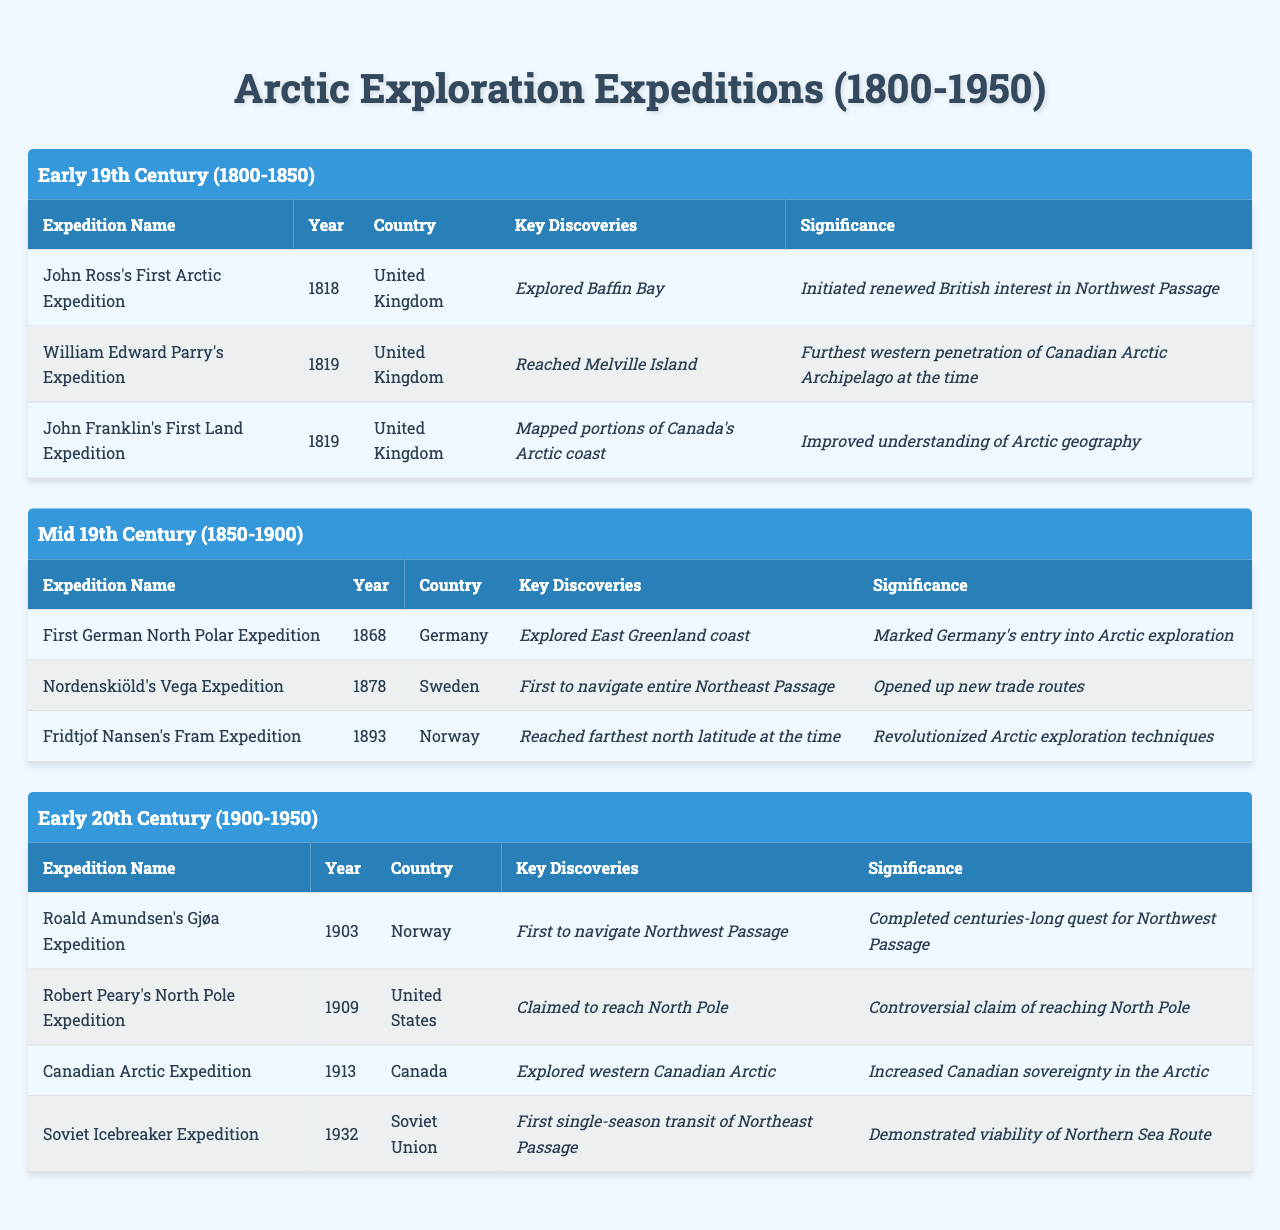What was the first recorded Arctic expedition in the 19th century? The table lists expeditions in chronological order. The first expedition under "Early 19th Century (1800-1850)" is John Ross's First Arctic Expedition in 1818.
Answer: John Ross's First Arctic Expedition Which country conducted the expedition that first navigated the entire Northeast Passage? Looking at the "Mid 19th Century (1850-1900)" era, the Nordenskiöld's Vega Expedition in 1878 is noted for being the first to navigate the entire Northeast Passage, and it was conducted by Sweden.
Answer: Sweden How many expeditions occurred in the Early 20th Century? In the "Early 20th Century (1900-1950)" section, there are four listed expeditions: Roald Amundsen's Gjøa Expedition, Robert Peary's North Pole Expedition, Canadian Arctic Expedition, and Soviet Icebreaker Expedition.
Answer: Four Did the United States claim any significant Arctic territory in its expeditions? The table indicates that Robert Peary's North Pole Expedition in 1909 claimed to reach the North Pole, but this claim is marked as controversial. Therefore, yes, it suggests a claim, but the reliability is questioned.
Answer: Yes What was the significance of the Fram Expedition in 1893? The significance of Fridtjof Nansen's Fram Expedition, listed in the "Mid 19th Century (1850-1900)" era, is mentioned as having revolutionized Arctic exploration techniques, highlighting its importance in the history of exploration.
Answer: Revolutionized Arctic exploration techniques Which expedition had the year with the highest recorded date? By scanning through the table, the expedition with the highest year is the Soviet Icebreaker Expedition in 1932. Therefore, that is the answer.
Answer: 1932 Count the number of expeditions initiated by the United Kingdom. By examining the table across both the "Early 19th Century" and "Mid 19th Century" sections, there are three expeditions initiated by the United Kingdom: John Ross's First Arctic Expedition, William Edward Parry's Expedition, and John Franklin's First Land Expedition, totaling three.
Answer: Three Which expedition is associated with increased Canadian sovereignty in the Arctic? The table specifies that the Canadian Arctic Expedition in 1913 explored the western Canadian Arctic, and its significance is noted as having increased Canadian sovereignty in the region.
Answer: Canadian Arctic Expedition Was there a significant milestone reached by Norwegians in Arctic exploration? Yes, Roald Amundsen's Gjøa Expedition in 1903 is noted for being the first to navigate the Northwest Passage, marking a significant milestone in Norwegian Arctic exploration.
Answer: Yes Compare the significance of the 1868 German expedition to the 1878 Swedish expedition. The 1868 expedition (First German North Polar Expedition) marked Germany's entry into Arctic exploration, while the 1878 expedition (Nordenskiöld's Vega Expedition) is significant for opening up new trade routes. The Swedish expedition had broader implications for exploration and commerce, while the German expedition marked a national point in exploration.
Answer: Swedish expedition had broader implications 